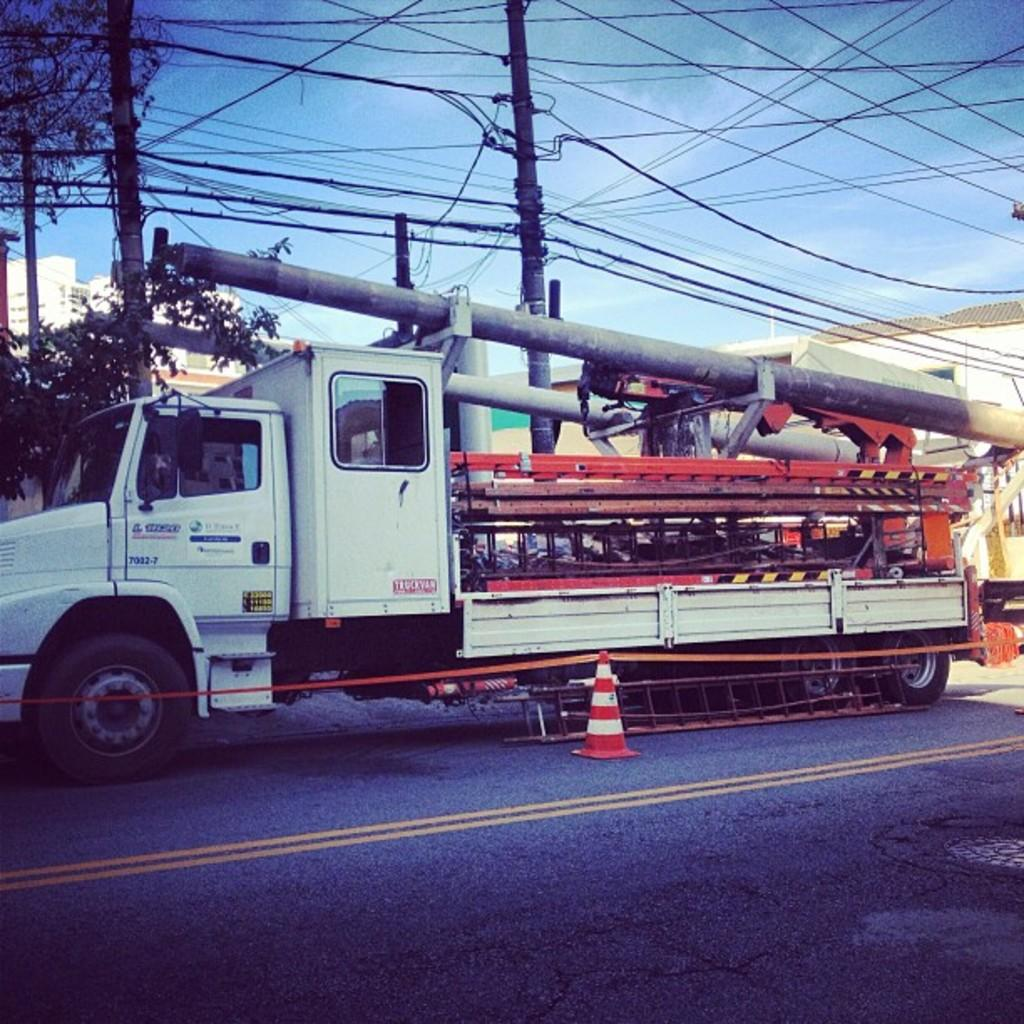What is the main subject of the image? The main subject of the image is a truck on the road. What is inside the truck? The truck contains machines, rods, and equipment. What can be seen in the background of the image? In the background, there are poles and wires, trees, and houses. What is the color of the sky in the image? The sky is blue in the image. How does the son feel about the disgusting cows in the image? There is no son or cows present in the image, so it is not possible to answer that question. 